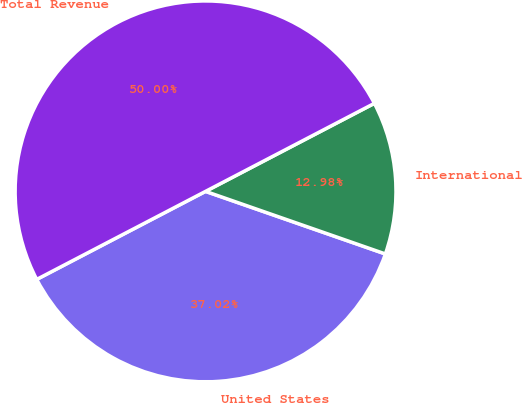Convert chart. <chart><loc_0><loc_0><loc_500><loc_500><pie_chart><fcel>United States<fcel>International<fcel>Total Revenue<nl><fcel>37.02%<fcel>12.98%<fcel>50.0%<nl></chart> 